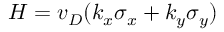<formula> <loc_0><loc_0><loc_500><loc_500>H = v _ { D } ( k _ { x } \sigma _ { x } + k _ { y } \sigma _ { y } )</formula> 